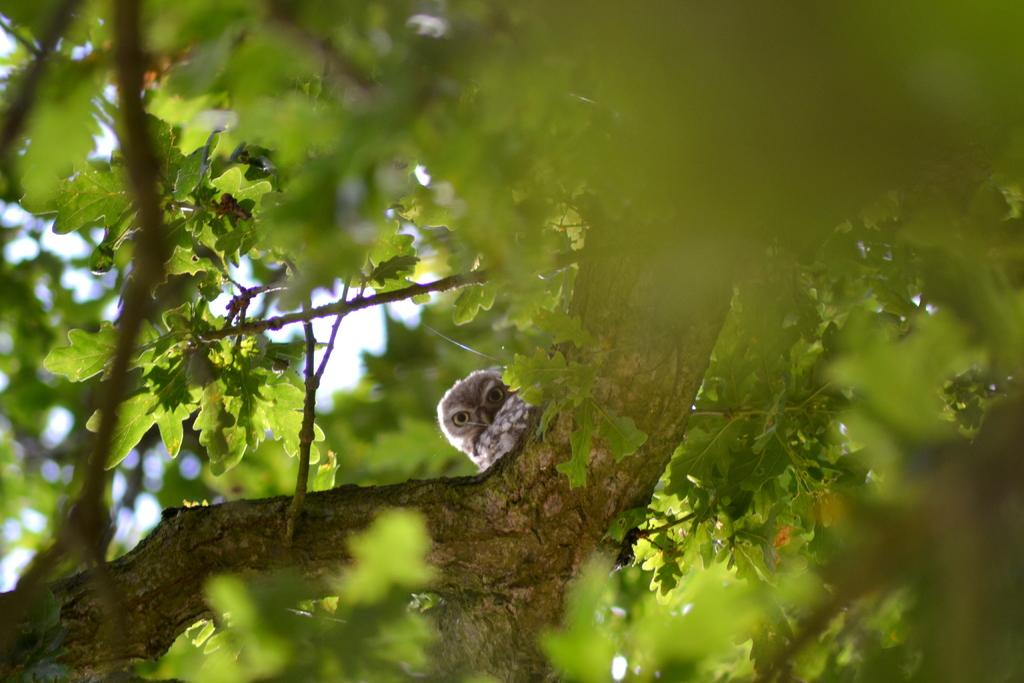What animal is present in the image? There is an owl in the image. Where is the owl located? The owl is on a branch in the image. What type of plant is visible in the image? There is a tree with leaves and branches in the image. What type of plastic material can be seen in the image? There is no plastic material present in the image. What kind of crook is visible in the image? There is no crook present in the image. 